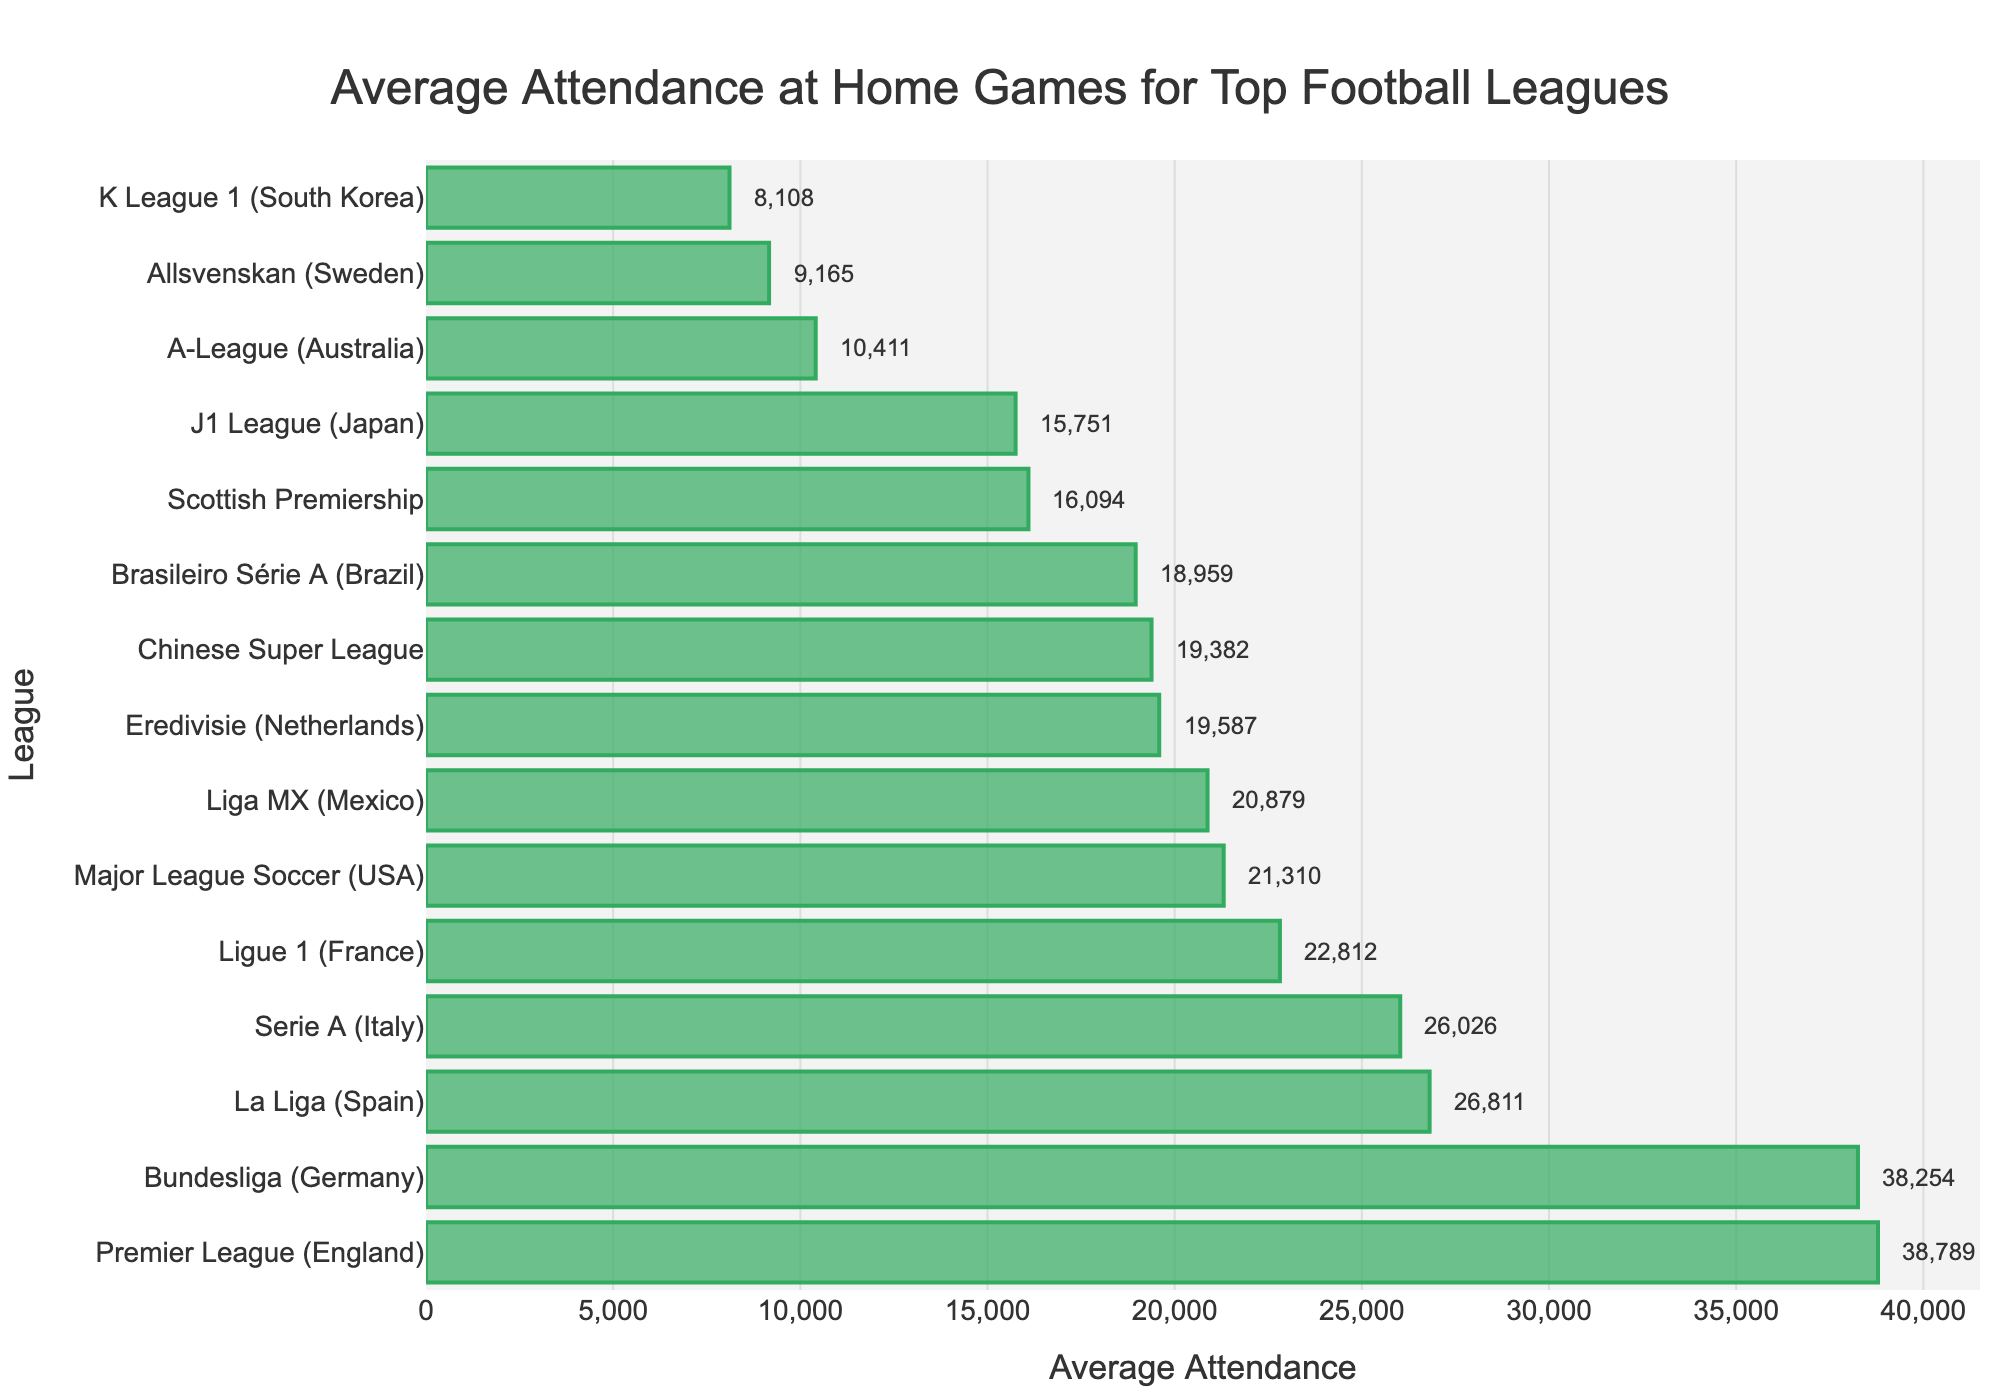Which league has the highest average attendance at home games? By looking at the bar chart, the Premier League (England) has the longest bar, indicating the highest average attendance.
Answer: Premier League (England) Which league has the lowest average attendance at home games? By looking at the bar chart, the K League 1 (South Korea) has the shortest bar, indicating the lowest average attendance.
Answer: K League 1 (South Korea) What is the combined average attendance of the Premier League (England) and Bundesliga (Germany)? The average attendance for the Premier League is 38,789 and for Bundesliga is 38,254. Summing these values: 38,789 + 38,254 = 77,043.
Answer: 77,043 Which league's average attendance is closest to 20,000? By inspecting the bar chart, the Liga MX (Mexico) and Chinese Super League are closest to 20,000 with values of 20,879, and 19,382 respectively. But, Liga MX is closer.
Answer: Liga MX (Mexico) Is the average attendance of La Liga (Spain) higher or lower than Serie A (Italy)? By comparing the bars, La Liga (Spain) has a longer bar, indicating a higher average attendance than Serie A (Italy).
Answer: Higher What is the average difference between the attendance of the league with the highest and lowest average attendance? Premier League (England) has the highest with 38,789, and K League 1 (South Korea) has the lowest with 8,108. Calculating the difference: 38,789 - 8,108 = 30,681.
Answer: 30,681 Which three leagues have the highest average attendance, and what is their total combined average? The three leagues with the highest average attendance are Premier League (England), Bundesliga (Germany), and La Liga (Spain). Sum their averages: 38,789 + 38,254 + 26,811 = 103,854.
Answer: Premier League (England), Bundesliga (Germany), La Liga (Spain); 103,854 Is the combined average attendance of Ligue 1 (France) and Major League Soccer (USA) greater than that of Serie A (Italy) and La Liga (Spain)? Calculate combined averages for each pair: Ligue 1 and MLS: 22,812 + 21,310 = 44,122; Serie A and La Liga: 26,026 + 26,811 = 52,837. 44,122 is less than 52,837.
Answer: No What is the average attendance of the leagues from continents other than Europe? Consider USA (21,310), Mexico (20,879), China (19,382), Brazil (18,959), Japan (15,751), Australia (10,411), South Korea (8,108). Sum these 7 values and then divide by number of values: (21,310 + 20,879 + 19,382 + 18,959 + 15,751 + 10,411 + 8,108) / 7 = 114,800 / 7 ≈ 16,400.
Answer: ≈ 16,400 